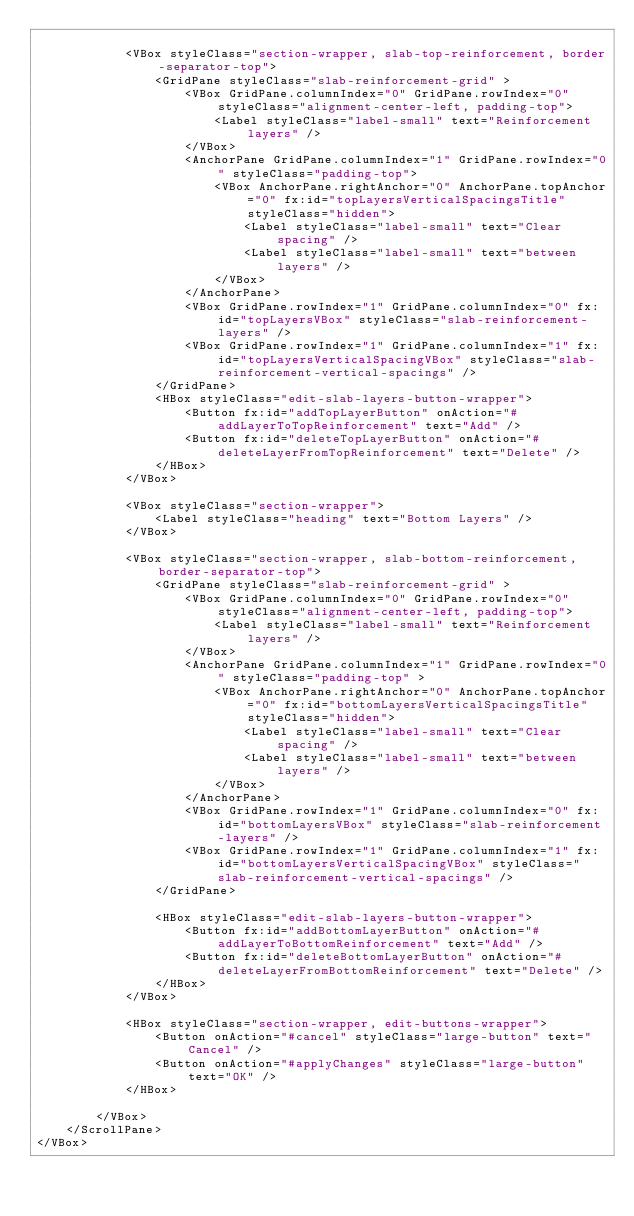<code> <loc_0><loc_0><loc_500><loc_500><_XML_>
            <VBox styleClass="section-wrapper, slab-top-reinforcement, border-separator-top">
                <GridPane styleClass="slab-reinforcement-grid" >
                    <VBox GridPane.columnIndex="0" GridPane.rowIndex="0" styleClass="alignment-center-left, padding-top">
                        <Label styleClass="label-small" text="Reinforcement layers" />
                    </VBox>
                    <AnchorPane GridPane.columnIndex="1" GridPane.rowIndex="0" styleClass="padding-top">
                        <VBox AnchorPane.rightAnchor="0" AnchorPane.topAnchor="0" fx:id="topLayersVerticalSpacingsTitle" styleClass="hidden">
                            <Label styleClass="label-small" text="Clear spacing" />
                            <Label styleClass="label-small" text="between layers" />
                        </VBox>
                    </AnchorPane>
                    <VBox GridPane.rowIndex="1" GridPane.columnIndex="0" fx:id="topLayersVBox" styleClass="slab-reinforcement-layers" />
                    <VBox GridPane.rowIndex="1" GridPane.columnIndex="1" fx:id="topLayersVerticalSpacingVBox" styleClass="slab-reinforcement-vertical-spacings" />
                </GridPane>
                <HBox styleClass="edit-slab-layers-button-wrapper">
                    <Button fx:id="addTopLayerButton" onAction="#addLayerToTopReinforcement" text="Add" />
                    <Button fx:id="deleteTopLayerButton" onAction="#deleteLayerFromTopReinforcement" text="Delete" />
                </HBox>
            </VBox>

            <VBox styleClass="section-wrapper">
                <Label styleClass="heading" text="Bottom Layers" />
            </VBox>

            <VBox styleClass="section-wrapper, slab-bottom-reinforcement, border-separator-top">
                <GridPane styleClass="slab-reinforcement-grid" >
                    <VBox GridPane.columnIndex="0" GridPane.rowIndex="0" styleClass="alignment-center-left, padding-top">
                        <Label styleClass="label-small" text="Reinforcement layers" />
                    </VBox>
                    <AnchorPane GridPane.columnIndex="1" GridPane.rowIndex="0" styleClass="padding-top" >
                        <VBox AnchorPane.rightAnchor="0" AnchorPane.topAnchor="0" fx:id="bottomLayersVerticalSpacingsTitle" styleClass="hidden">
                            <Label styleClass="label-small" text="Clear spacing" />
                            <Label styleClass="label-small" text="between layers" />
                        </VBox>
                    </AnchorPane>
                    <VBox GridPane.rowIndex="1" GridPane.columnIndex="0" fx:id="bottomLayersVBox" styleClass="slab-reinforcement-layers" />
                    <VBox GridPane.rowIndex="1" GridPane.columnIndex="1" fx:id="bottomLayersVerticalSpacingVBox" styleClass="slab-reinforcement-vertical-spacings" />
                </GridPane>

                <HBox styleClass="edit-slab-layers-button-wrapper">
                    <Button fx:id="addBottomLayerButton" onAction="#addLayerToBottomReinforcement" text="Add" />
                    <Button fx:id="deleteBottomLayerButton" onAction="#deleteLayerFromBottomReinforcement" text="Delete" />
                </HBox>
            </VBox>

            <HBox styleClass="section-wrapper, edit-buttons-wrapper">
                <Button onAction="#cancel" styleClass="large-button" text="Cancel" />
                <Button onAction="#applyChanges" styleClass="large-button" text="OK" />
            </HBox>

        </VBox>
    </ScrollPane>
</VBox>
</code> 